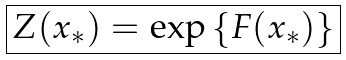Convert formula to latex. <formula><loc_0><loc_0><loc_500><loc_500>\boxed { Z ( x _ { * } ) = \exp \left \{ F ( x _ { * } ) \right \} }</formula> 